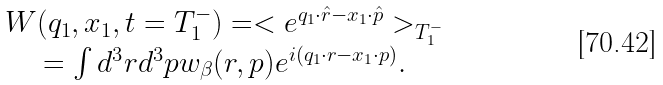Convert formula to latex. <formula><loc_0><loc_0><loc_500><loc_500>\begin{array} { c } W ( { q } _ { 1 } , { x } _ { 1 } , t = T _ { 1 } ^ { - } ) = < e ^ { { q } _ { 1 } \cdot { \hat { r } } - { x } _ { 1 } \cdot { \hat { p } } } > _ { T _ { 1 } ^ { - } } \\ = \int { d ^ { 3 } { r } d ^ { 3 } { p } w _ { \beta } ( { r } , { p } ) e ^ { i ( { q } _ { 1 } \cdot { r } - { x } _ { 1 } \cdot { p } ) } } . \end{array}</formula> 